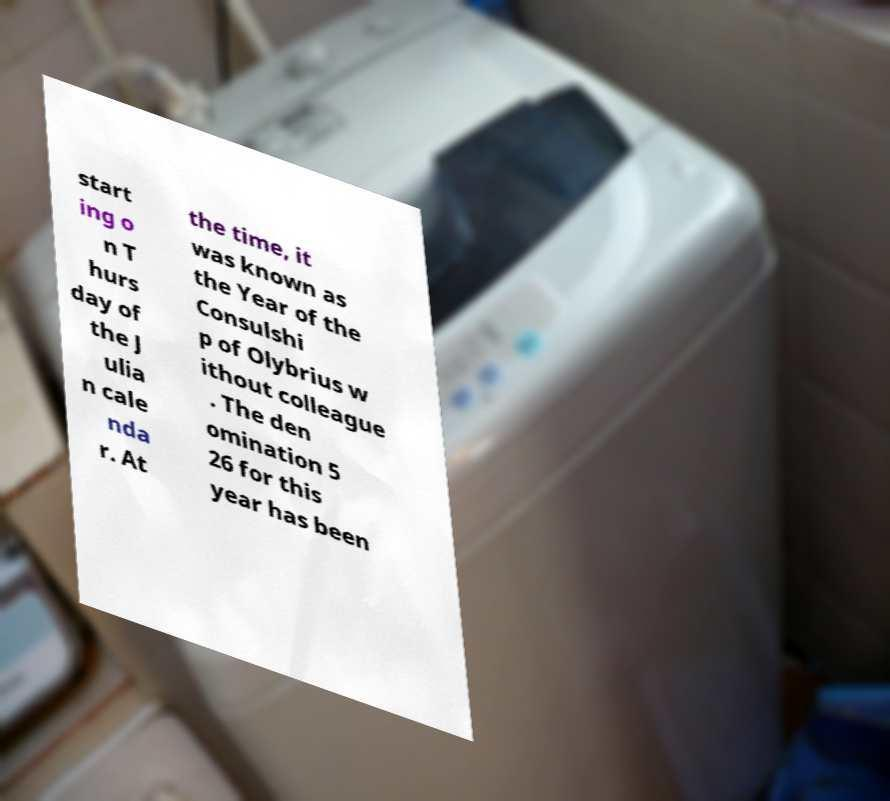Could you assist in decoding the text presented in this image and type it out clearly? start ing o n T hurs day of the J ulia n cale nda r. At the time, it was known as the Year of the Consulshi p of Olybrius w ithout colleague . The den omination 5 26 for this year has been 